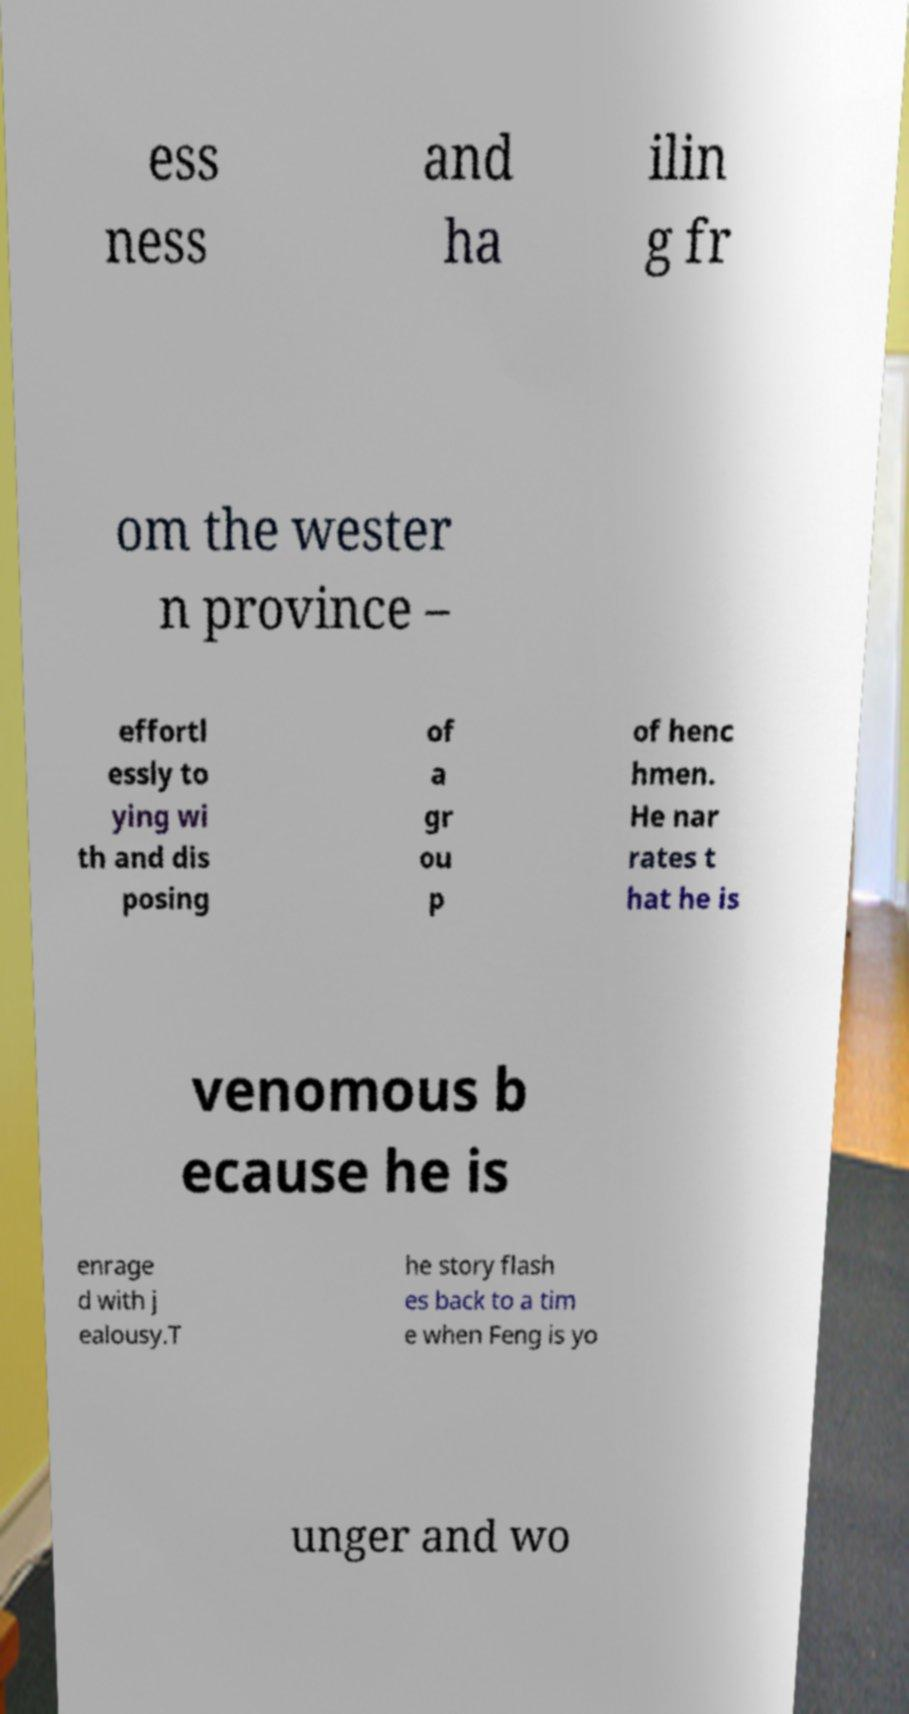There's text embedded in this image that I need extracted. Can you transcribe it verbatim? ess ness and ha ilin g fr om the wester n province – effortl essly to ying wi th and dis posing of a gr ou p of henc hmen. He nar rates t hat he is venomous b ecause he is enrage d with j ealousy.T he story flash es back to a tim e when Feng is yo unger and wo 